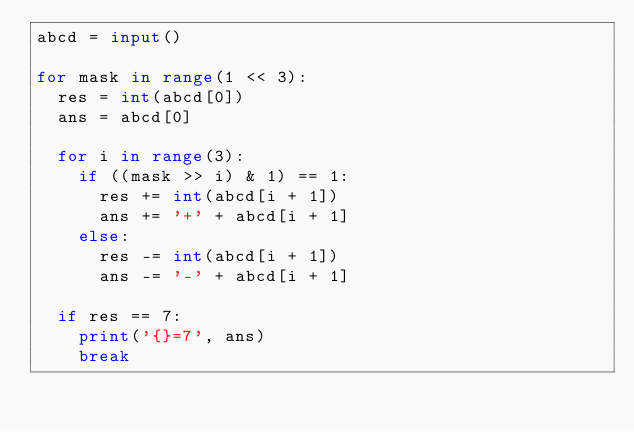<code> <loc_0><loc_0><loc_500><loc_500><_Python_>abcd = input()

for mask in range(1 << 3):
  res = int(abcd[0])
  ans = abcd[0]
  
  for i in range(3):
    if ((mask >> i) & 1) == 1:
      res += int(abcd[i + 1])
      ans += '+' + abcd[i + 1]
    else:
      res -= int(abcd[i + 1])
      ans -= '-' + abcd[i + 1]
  
  if res == 7:
    print('{}=7', ans)
    break</code> 